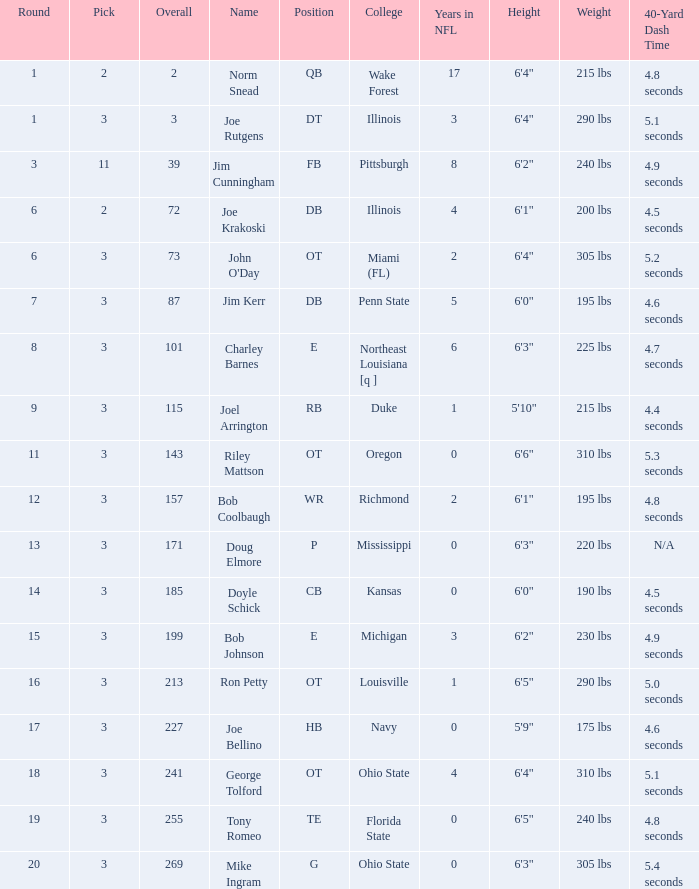How many overalls have charley barnes as the name, with a pick less than 3? None. 